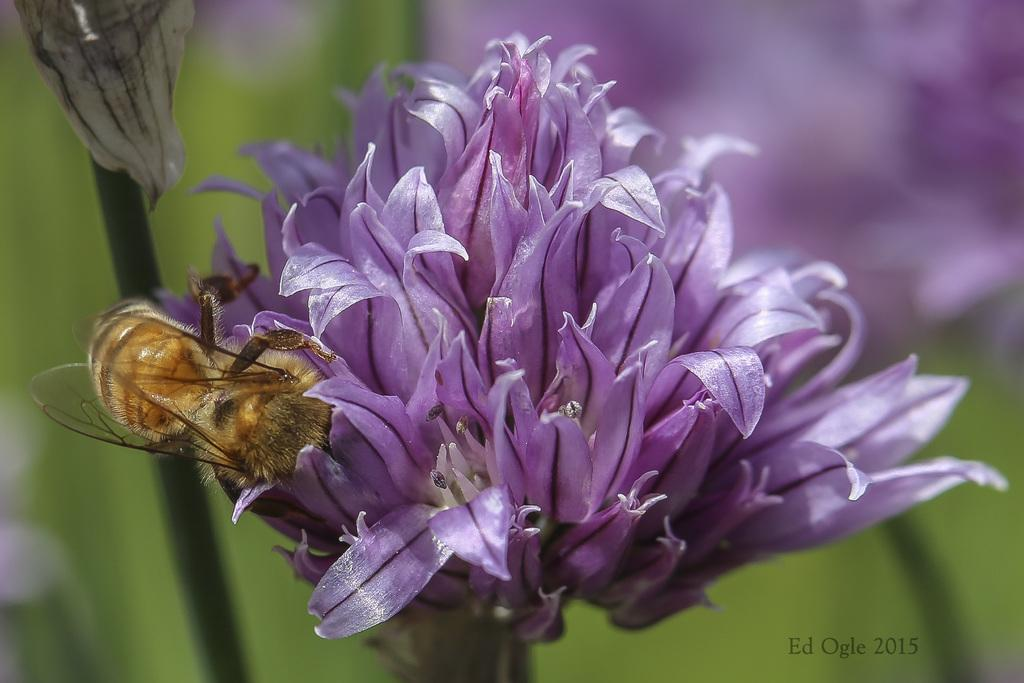What color is the flower in the image? The flower in the image is violet. What is on the flower in the image? There is an insect on the flower in the image. What can be seen on the left side of the image? There is a plant on the left side of the image. What is visible in the background of the image? There are plants with flowers in the background of the image. What letters can be seen on the rose in the image? There is no rose present in the image, and therefore no letters can be seen on it. 